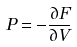Convert formula to latex. <formula><loc_0><loc_0><loc_500><loc_500>P = - \frac { \partial F } { \partial V }</formula> 